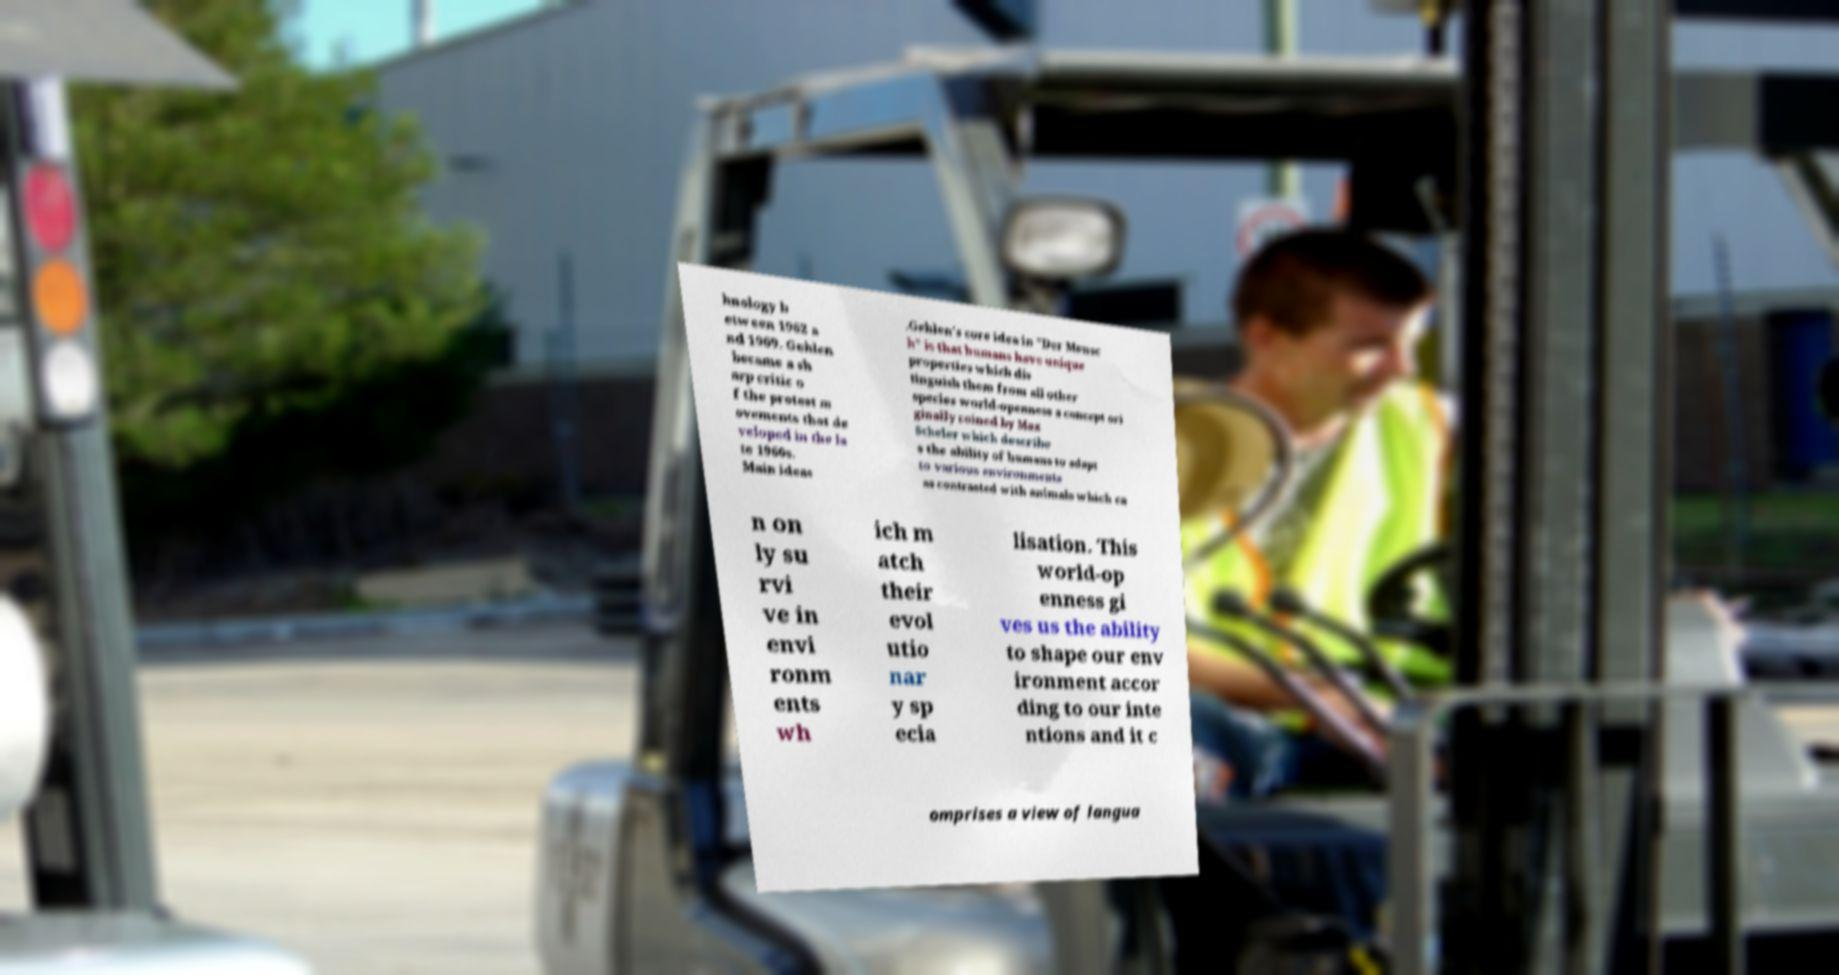Can you read and provide the text displayed in the image?This photo seems to have some interesting text. Can you extract and type it out for me? hnology b etween 1962 a nd 1969. Gehlen became a sh arp critic o f the protest m ovements that de veloped in the la te 1960s. Main ideas .Gehlen's core idea in "Der Mensc h" is that humans have unique properties which dis tinguish them from all other species world-openness a concept ori ginally coined by Max Scheler which describe s the ability of humans to adapt to various environments as contrasted with animals which ca n on ly su rvi ve in envi ronm ents wh ich m atch their evol utio nar y sp ecia lisation. This world-op enness gi ves us the ability to shape our env ironment accor ding to our inte ntions and it c omprises a view of langua 